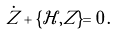<formula> <loc_0><loc_0><loc_500><loc_500>\dot { Z } + \{ \mathcal { H } , Z \} = 0 \, .</formula> 